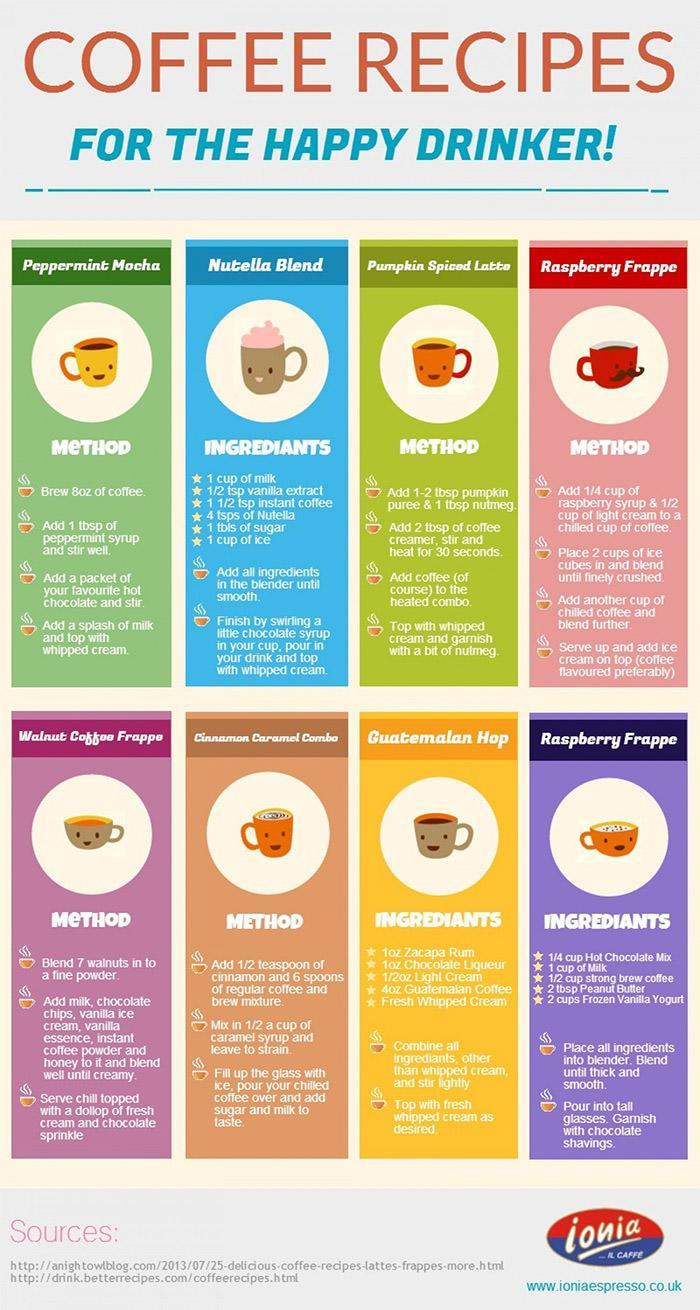How many sources are listed?
Answer the question with a short phrase. 2 How many coffee recipes are given here? 8 